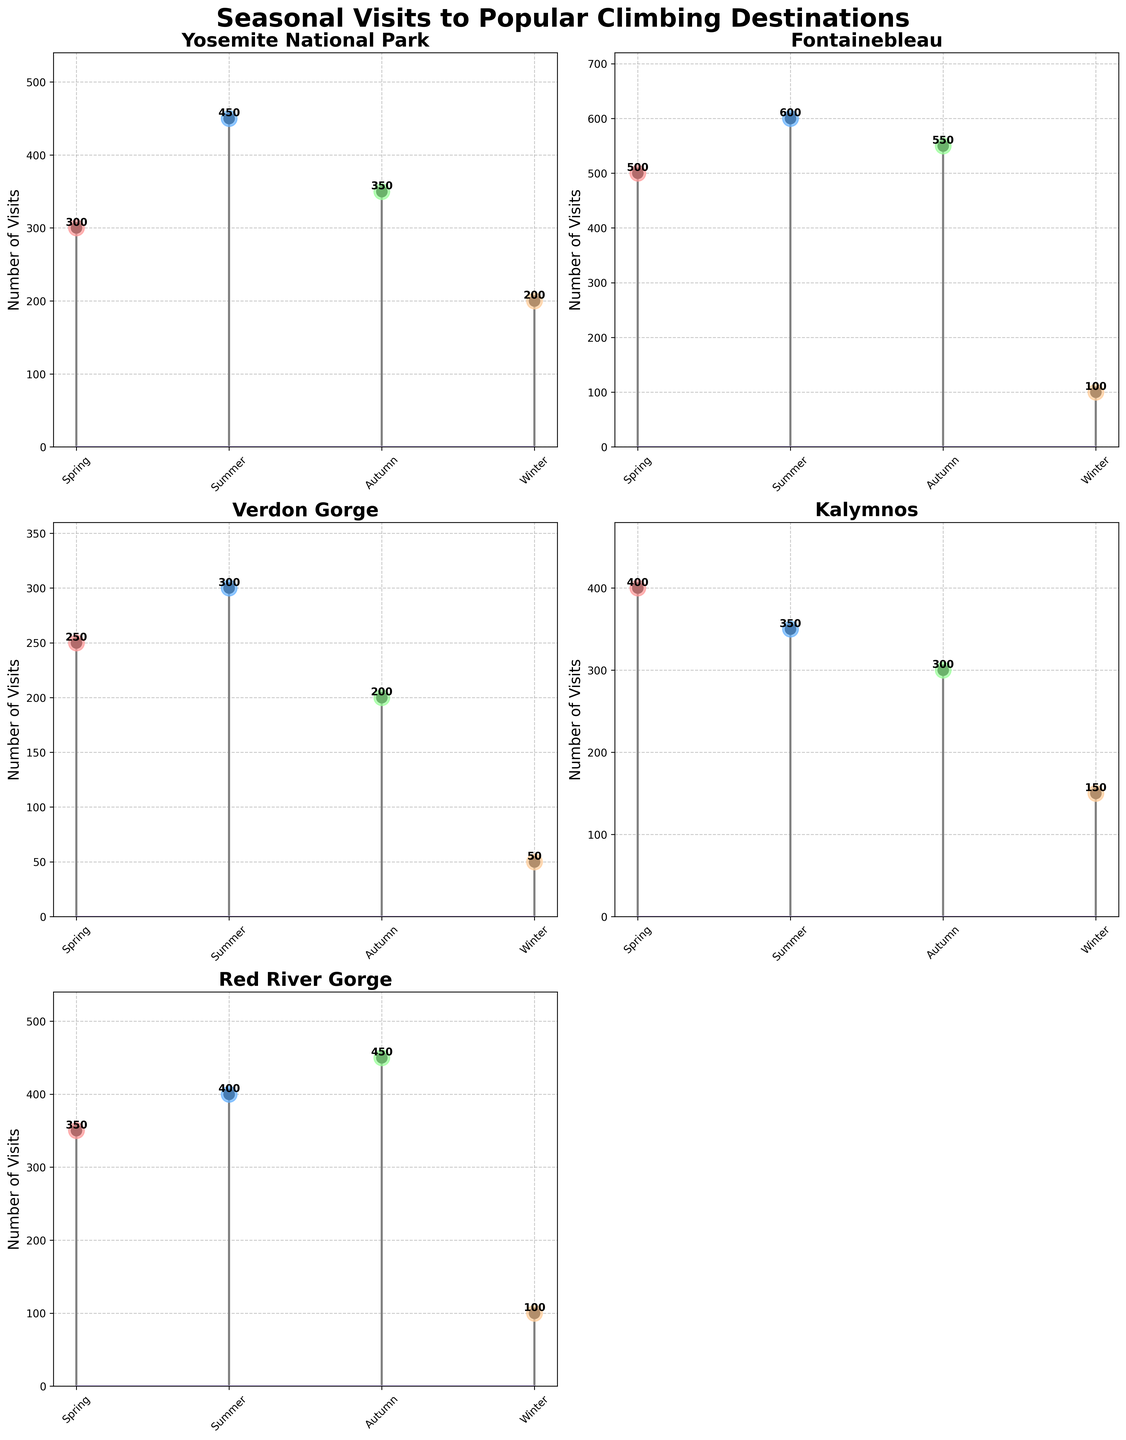What's the title of the figure? The title is located at the top of the figure, in bold and larger font size. The title is "Seasonal Visits to Popular Climbing Destinations".
Answer: Seasonal Visits to Popular Climbing Destinations What are the seasons represented on the x-axis? The x-axis ticks are labeled with the seasons, which can be seen at the bottom of each subplot. The seasons are "Spring", "Summer", "Autumn", and "Winter".
Answer: Spring, Summer, Autumn, Winter Which climbing destination has the highest visits in Summer? By comparing the peaks of the stems in the Summer for each subplot, Fontainebleau has the highest number of visits in Summer, with a value of 600.
Answer: Fontainebleau What's the total number of visits to Red River Gorge over all seasons? Summing the visits for Red River Gorge: Spring (350) + Summer (400) + Autumn (450) + Winter (100) gives us the total number of visits.
Answer: 1300 For which destination is Winter the least popular season, and what is the number of visits? By observing the lowest points on the plots for Winter, Verdon Gorge has the least number of visits in this season with a value of 50.
Answer: Verdon Gorge, 50 Which destination has the most balanced distribution of visits across all seasons? Looking for the plot where the heights of the stems are the closest: Yosemite National Park shows visits ranging from 200 to 450, which is more balanced compared to other destinations.
Answer: Yosemite National Park In which season does Fontainebleau experience the biggest drop in visits compared to the previous season? Fontainebleau's biggest drop is from Autumn (550) to Winter (100). The difference is 450.
Answer: Winter On average, how many visits does Kalymnos get per season? The average number of visits is found by summing visits in each season - 400 (Spring) + 350 (Summer) + 300 (Autumn) + 150 (Winter) and dividing by 4.
Answer: 300 Which location has the smallest fluctuation in visit numbers throughout the year? Evaluating the difference between the highest and lowest visit numbers for each location, Yosemite National Park's fluctuation is from 200 to 450, which is smaller compared to others.
Answer: Yosemite National Park What's the difference in the number of visits between Spring and Autumn at Yosemite National Park? The visit count in Spring is 300 and in Autumn is 350. The difference is calculated as 350 - 300.
Answer: 50 